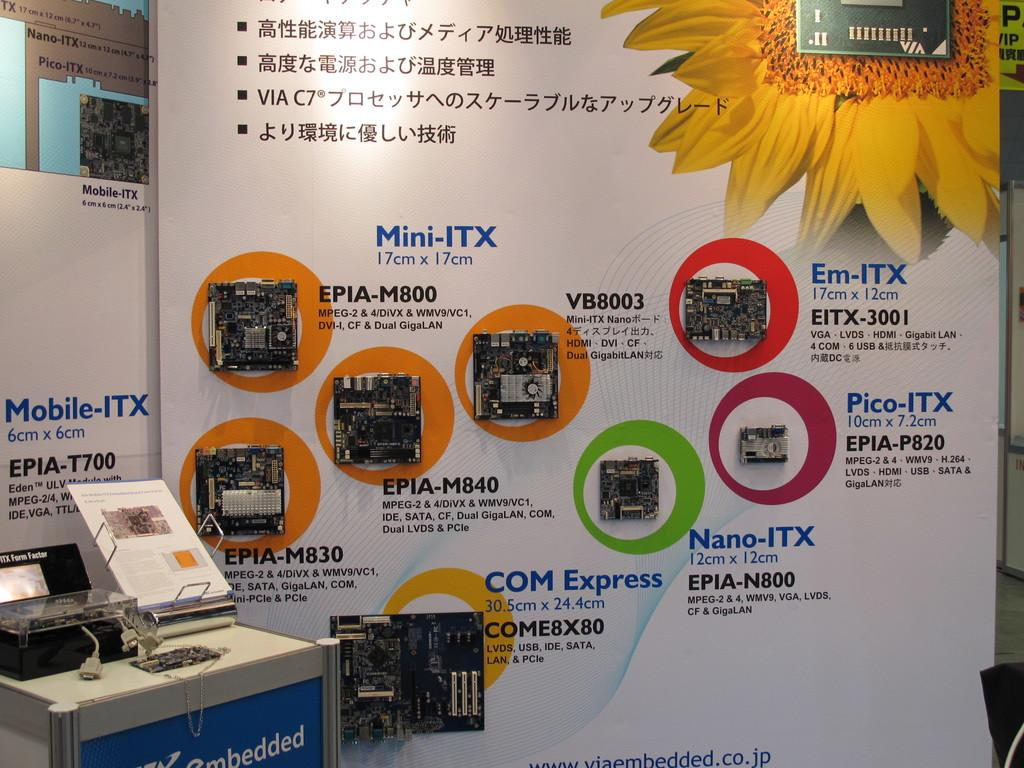What is the main object on the table in the image? There is a printing machine on a table in the image. What else can be seen on the table? There are papers in the image. What is the purpose of the papers on the table? The papers may be used for printing or as part of the printing process. Is there any other information visible in the image? Yes, there is an advertisement in the image. How many bells are hanging from the printing machine in the image? There are no bells present in the image. What type of cap is being worn by the person operating the printing machine in the image? There is no person operating the printing machine in the image. 